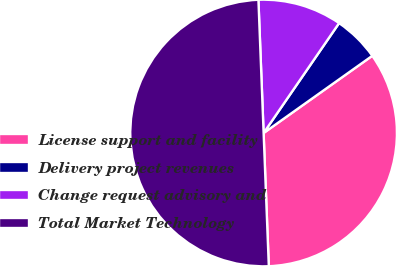Convert chart to OTSL. <chart><loc_0><loc_0><loc_500><loc_500><pie_chart><fcel>License support and facility<fcel>Delivery project revenues<fcel>Change request advisory and<fcel>Total Market Technology<nl><fcel>34.21%<fcel>5.59%<fcel>10.2%<fcel>50.0%<nl></chart> 